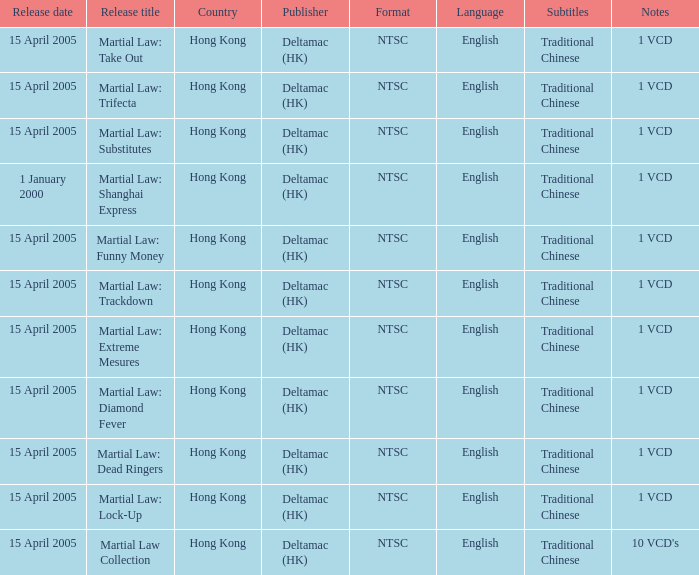Which publisher released Martial Law: Substitutes? Deltamac (HK). 